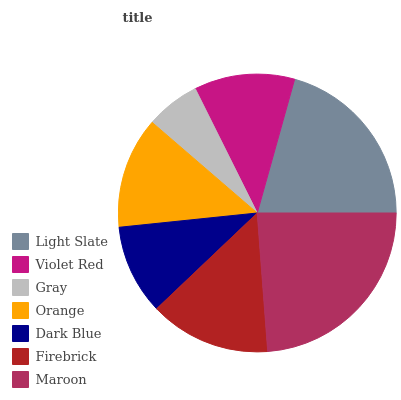Is Gray the minimum?
Answer yes or no. Yes. Is Maroon the maximum?
Answer yes or no. Yes. Is Violet Red the minimum?
Answer yes or no. No. Is Violet Red the maximum?
Answer yes or no. No. Is Light Slate greater than Violet Red?
Answer yes or no. Yes. Is Violet Red less than Light Slate?
Answer yes or no. Yes. Is Violet Red greater than Light Slate?
Answer yes or no. No. Is Light Slate less than Violet Red?
Answer yes or no. No. Is Orange the high median?
Answer yes or no. Yes. Is Orange the low median?
Answer yes or no. Yes. Is Maroon the high median?
Answer yes or no. No. Is Gray the low median?
Answer yes or no. No. 